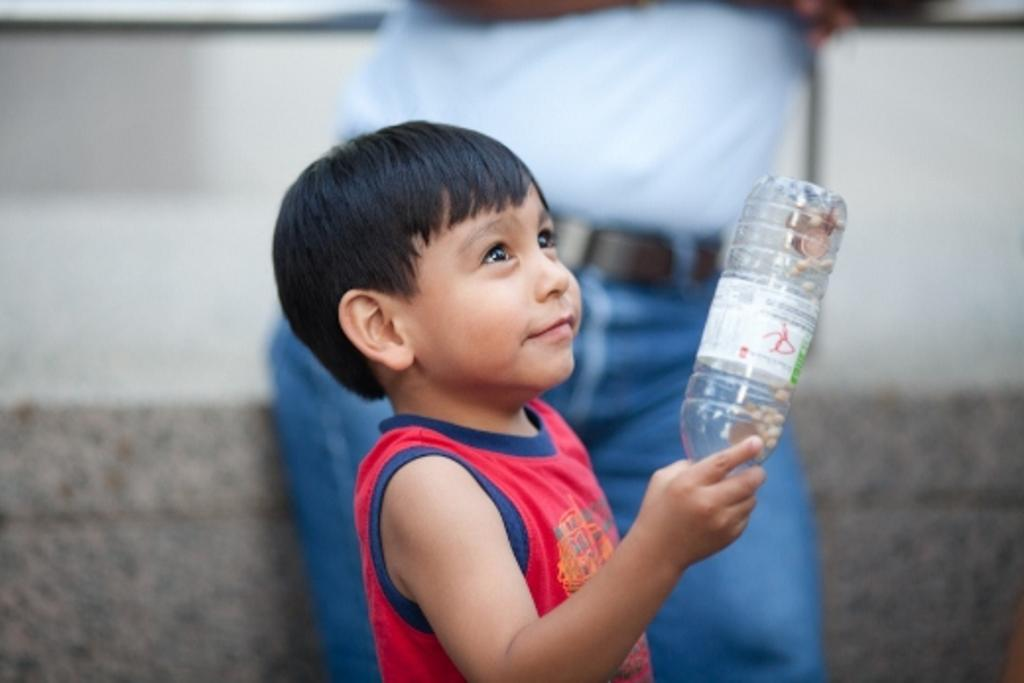What is the main subject of the picture? The main subject of the picture is a boy. What is the boy holding in his hand? The boy is holding a bottle in his hand. Can you describe another person in the picture? Yes, there is a person standing in the picture. What grade is the boy in, based on the picture? There is no information about the boy's grade in the picture. 